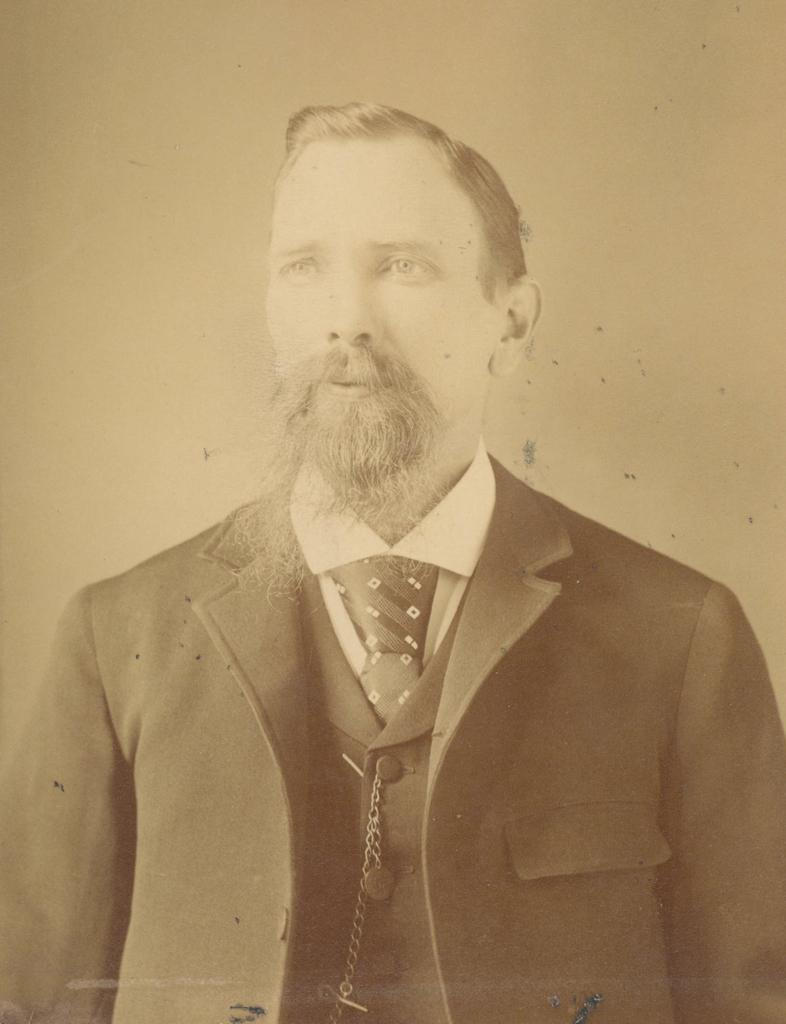Who is present in the image? There is a person in the image. What is the person wearing? The person is wearing a dress. What is the color scheme of the image? The image is in black and white. What type of juice is the person holding in the image? There is no juice present in the image; it is a person wearing a dress in a black and white image. 